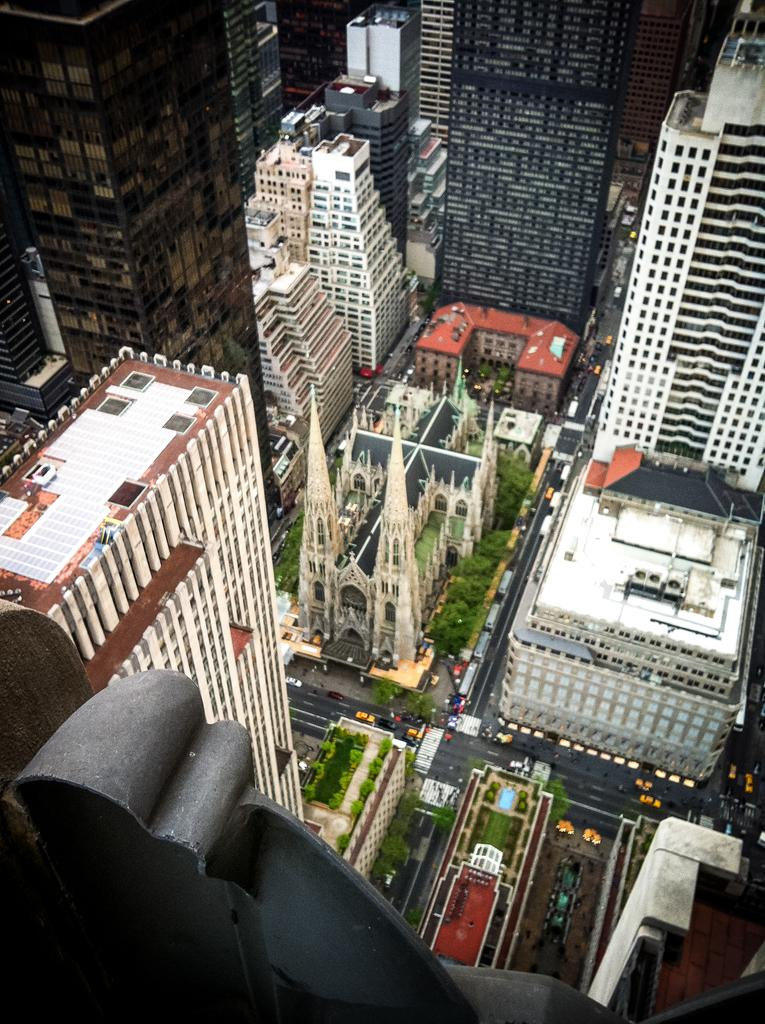What type of view is shown in the image? The image shows a top view of a street. What structures can be seen in the image? There are many buildings in the image. What natural elements are present in the image? Trees are present in the image. What man-made elements are visible in the image? Roads are visible in the image. What type of objects are in the image that move? Vehicles are in the image. What type of food is being represented by the vehicles in the image? There is no food represented by the vehicles in the image; they are simply vehicles moving on the roads. 